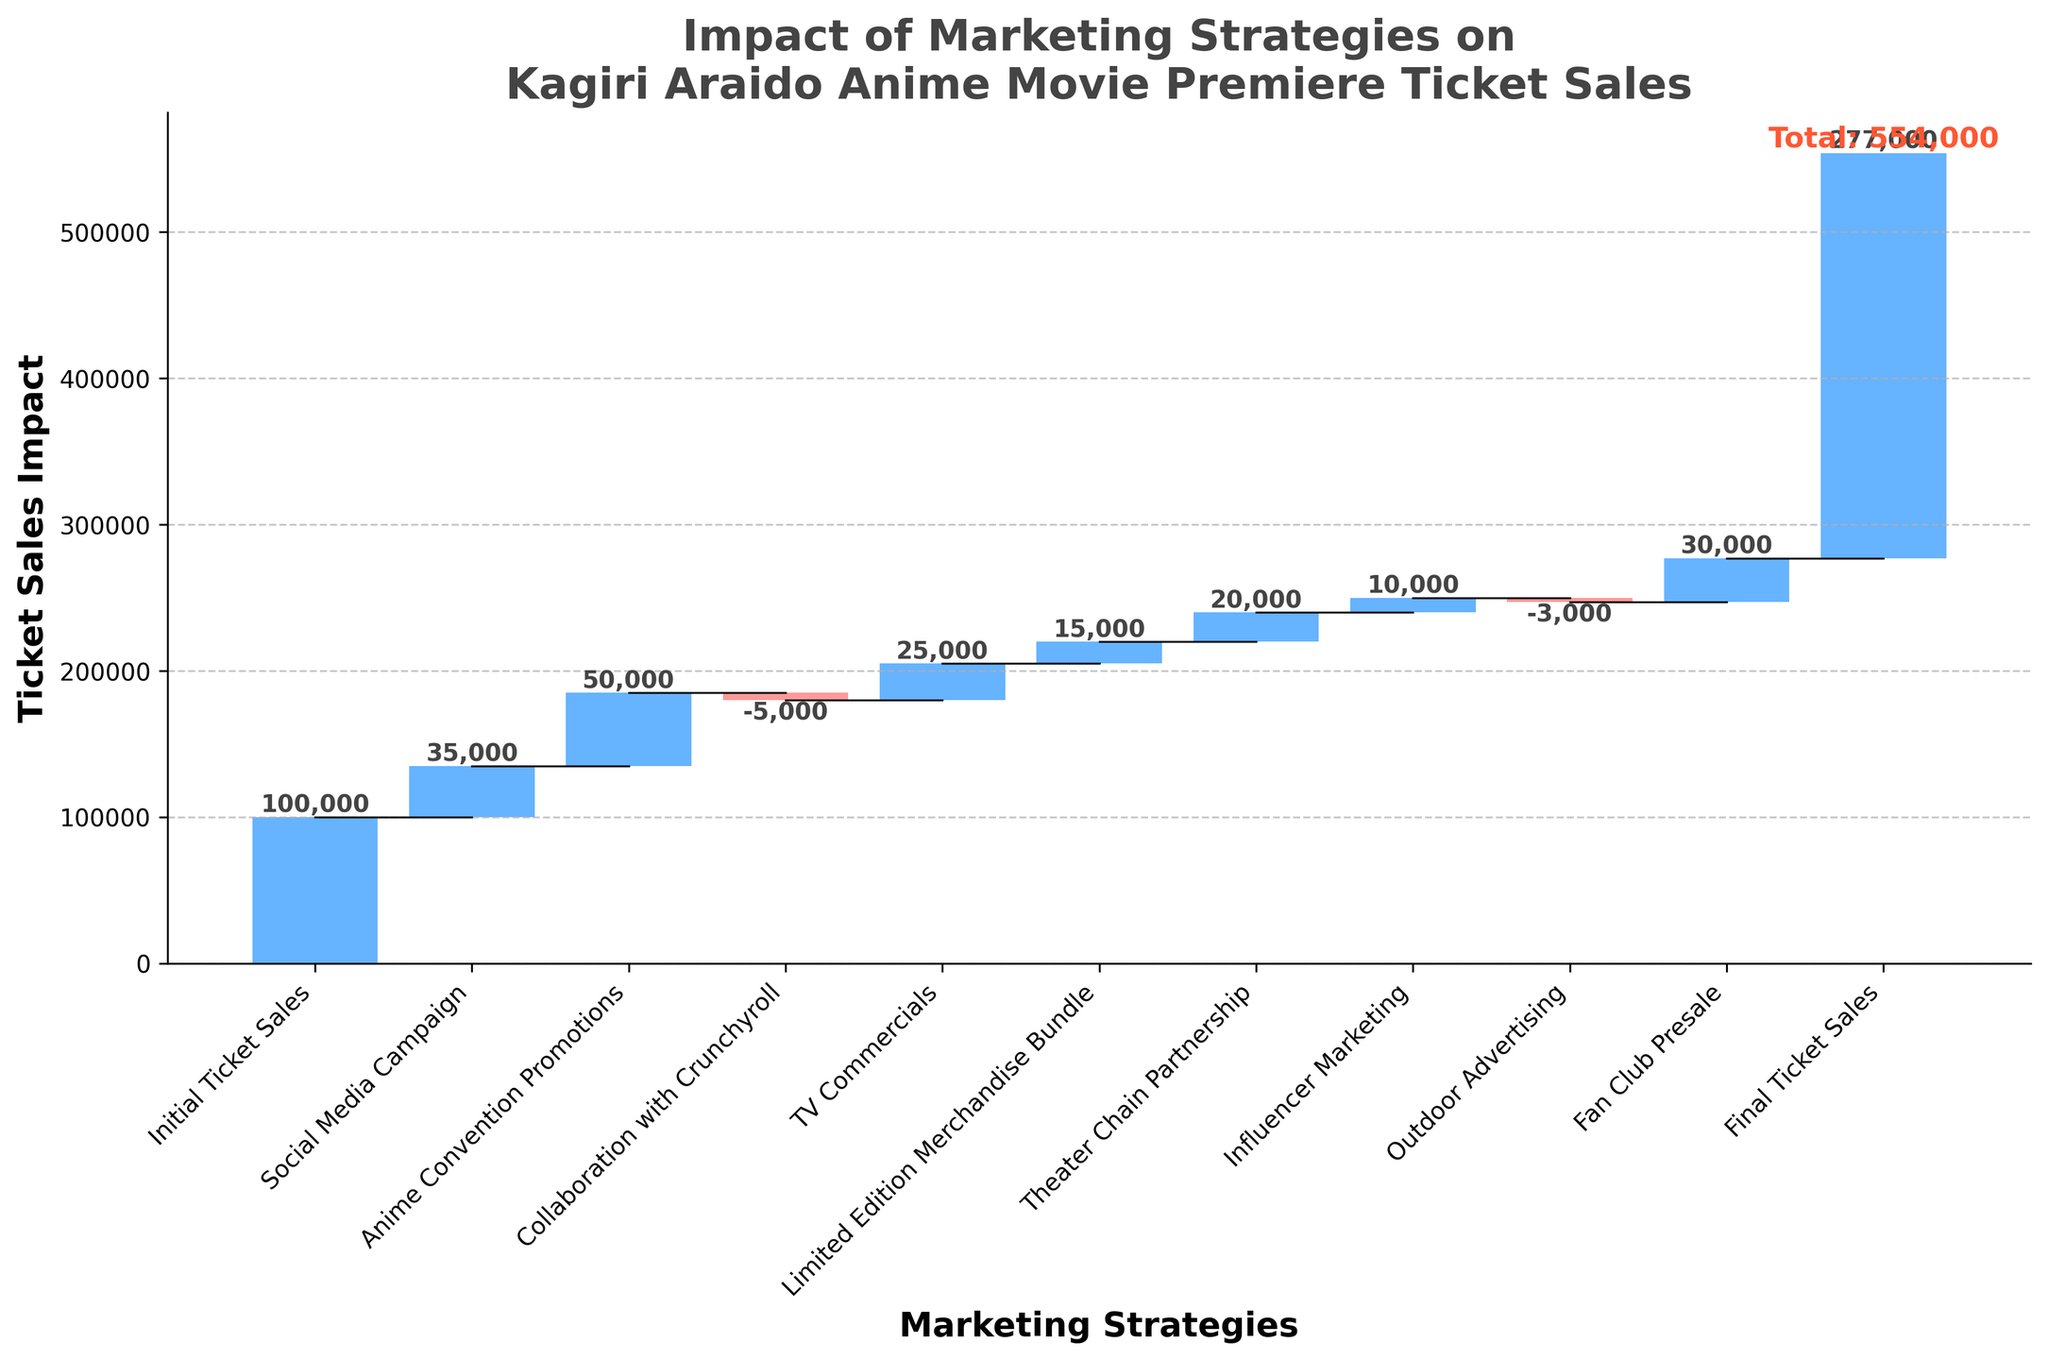What is the title of the chart? The title of the chart is displayed prominently at the top, summarizing the primary content of the chart.
Answer: Impact of Marketing Strategies on Kagiri Araido Anime Movie Premiere Ticket Sales Which marketing strategy had the biggest positive impact on ticket sales? The highest upward bar in the chart indicates the strategy with the largest positive value.
Answer: Anime Convention Promotions (+50,000) How is the impact of Collaboration with Crunchyroll shown in the chart? The impact is shown as a bar with a negative value, interpreted by color and direction.
Answer: Negative impact (-5,000) What is the total ticket sales figure after considering all marketing strategies? The total ticket sales figure is displayed at the end of the cumulative sum as indicated in the chart.
Answer: 277,000 How many marketing strategies contributed positively to the ticket sales? Count the number of bars in the chart that are positive, i.e., extending upwards.
Answer: 7 Did TV Commercials have a greater impact than Influencer Marketing? Compare the height, and hence the values, of the bars labeled TV Commercials and Influencer Marketing.
Answer: Yes (+25,000 vs. +10,000) Calculate the net effect of Collaboration with Crunchyroll and Outdoor Advertising on ticket sales. Add the values (both negative) of Collaboration with Crunchyroll and Outdoor Advertising.
Answer: -8,000 Which marketing strategy had the smallest impact on ticket sales? Identify the bar with the smallest absolute value, regardless of direction (positive or negative).
Answer: Outdoor Advertising (-3,000) What was the initial number of ticket sales before any marketing strategies were considered? The initial value is represented by the first category in the waterfall chart.
Answer: 100,000 If Social Media Campaign and Limited Edition Merchandise Bundle were combined, what would their total impact be? Sum the values of Social Media Campaign and Limited Edition Merchandise Bundle.
Answer: +50,000 